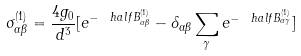<formula> <loc_0><loc_0><loc_500><loc_500>\sigma _ { \alpha \beta } ^ { ( 1 ) } = \frac { 4 g _ { 0 } } { d ^ { 3 } } [ e ^ { - \ h a l f B _ { \alpha \beta } ^ { ( 1 ) } } - \delta _ { \alpha \beta } \sum _ { \gamma } e ^ { - \ h a l f B _ { \alpha \gamma } ^ { ( 1 ) } } ]</formula> 